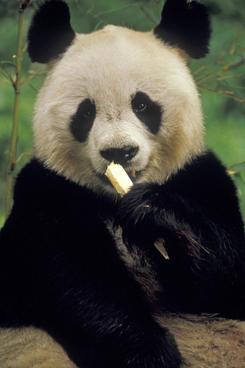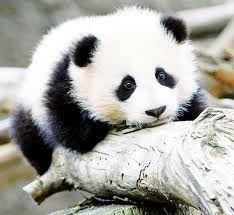The first image is the image on the left, the second image is the image on the right. Analyze the images presented: Is the assertion "There are two panda bears" valid? Answer yes or no. Yes. The first image is the image on the left, the second image is the image on the right. For the images displayed, is the sentence "In one of the images there is a mother panda with her baby." factually correct? Answer yes or no. No. 